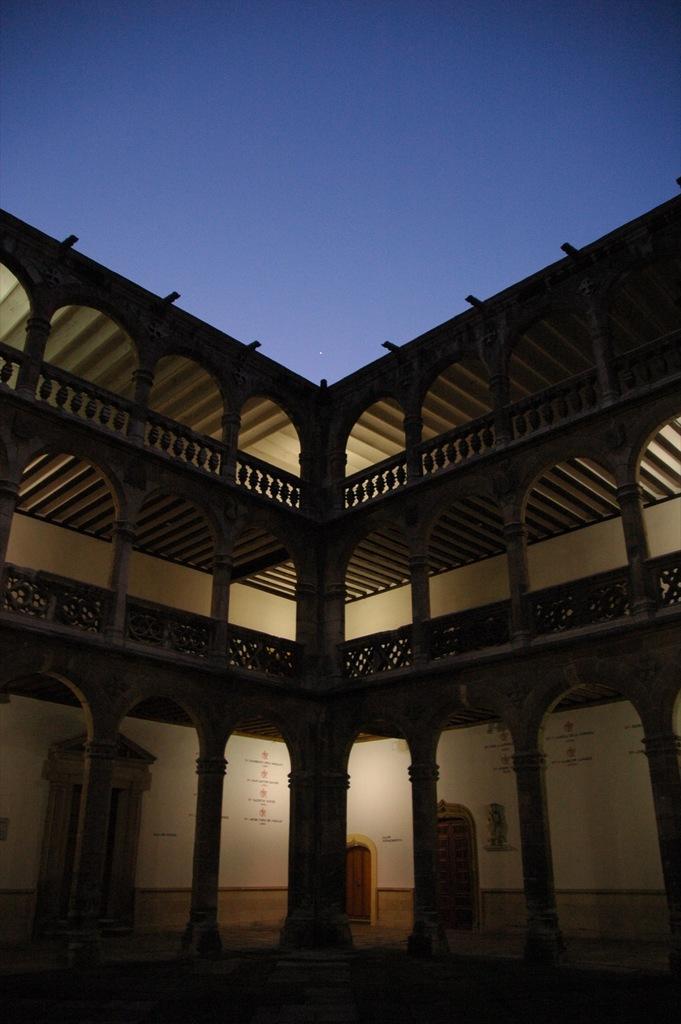In one or two sentences, can you explain what this image depicts? In this picture I can see a building and text on the walls. I can see doors and a blue sky. 